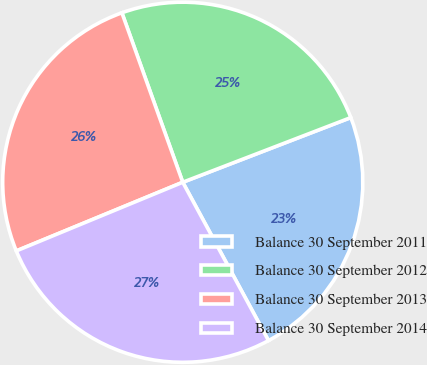<chart> <loc_0><loc_0><loc_500><loc_500><pie_chart><fcel>Balance 30 September 2011<fcel>Balance 30 September 2012<fcel>Balance 30 September 2013<fcel>Balance 30 September 2014<nl><fcel>22.95%<fcel>24.64%<fcel>25.74%<fcel>26.67%<nl></chart> 